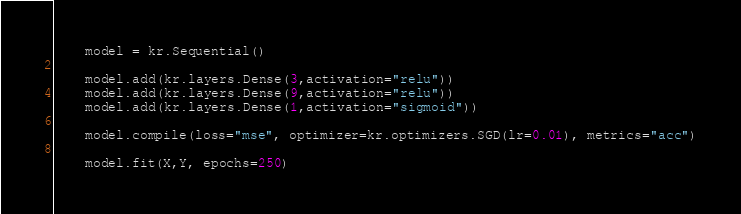<code> <loc_0><loc_0><loc_500><loc_500><_Python_>    model = kr.Sequential()

    model.add(kr.layers.Dense(3,activation="relu"))
    model.add(kr.layers.Dense(9,activation="relu"))
    model.add(kr.layers.Dense(1,activation="sigmoid"))

    model.compile(loss="mse", optimizer=kr.optimizers.SGD(lr=0.01), metrics="acc")

    model.fit(X,Y, epochs=250)</code> 